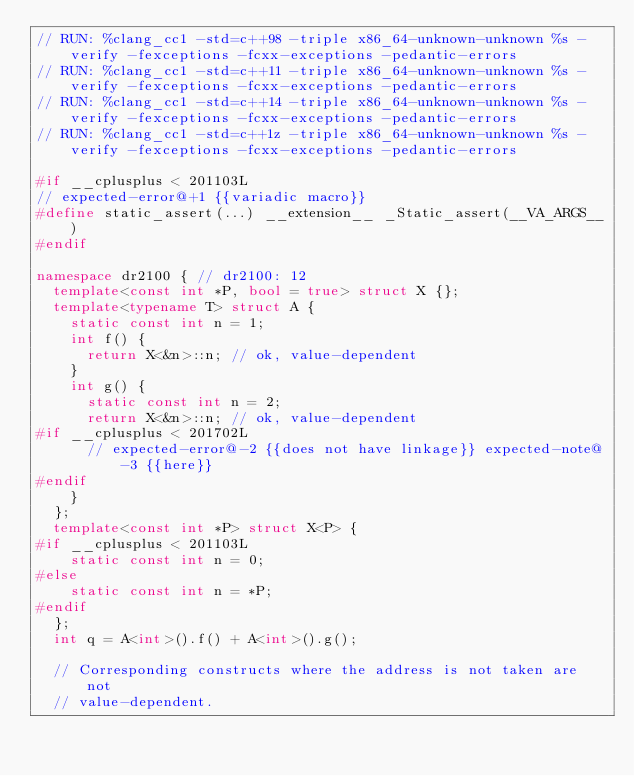<code> <loc_0><loc_0><loc_500><loc_500><_C++_>// RUN: %clang_cc1 -std=c++98 -triple x86_64-unknown-unknown %s -verify -fexceptions -fcxx-exceptions -pedantic-errors
// RUN: %clang_cc1 -std=c++11 -triple x86_64-unknown-unknown %s -verify -fexceptions -fcxx-exceptions -pedantic-errors
// RUN: %clang_cc1 -std=c++14 -triple x86_64-unknown-unknown %s -verify -fexceptions -fcxx-exceptions -pedantic-errors
// RUN: %clang_cc1 -std=c++1z -triple x86_64-unknown-unknown %s -verify -fexceptions -fcxx-exceptions -pedantic-errors

#if __cplusplus < 201103L
// expected-error@+1 {{variadic macro}}
#define static_assert(...) __extension__ _Static_assert(__VA_ARGS__)
#endif

namespace dr2100 { // dr2100: 12
  template<const int *P, bool = true> struct X {};
  template<typename T> struct A {
    static const int n = 1;
    int f() {
      return X<&n>::n; // ok, value-dependent
    }
    int g() {
      static const int n = 2;
      return X<&n>::n; // ok, value-dependent
#if __cplusplus < 201702L
      // expected-error@-2 {{does not have linkage}} expected-note@-3 {{here}}
#endif
    }
  };
  template<const int *P> struct X<P> {
#if __cplusplus < 201103L
    static const int n = 0;
#else
    static const int n = *P;
#endif
  };
  int q = A<int>().f() + A<int>().g();

  // Corresponding constructs where the address is not taken are not
  // value-dependent.</code> 